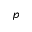<formula> <loc_0><loc_0><loc_500><loc_500>p</formula> 